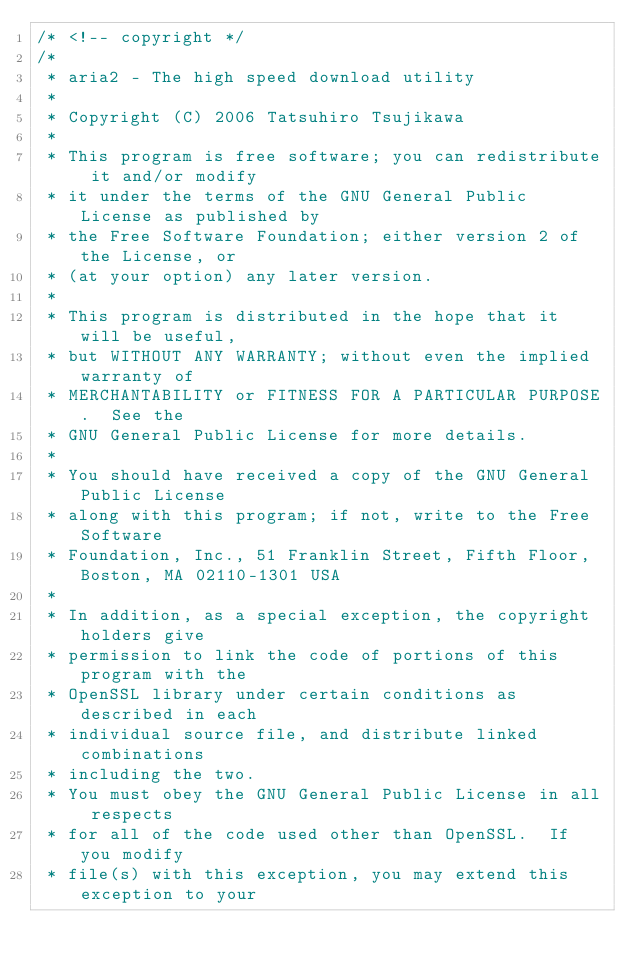Convert code to text. <code><loc_0><loc_0><loc_500><loc_500><_C++_>/* <!-- copyright */
/*
 * aria2 - The high speed download utility
 *
 * Copyright (C) 2006 Tatsuhiro Tsujikawa
 *
 * This program is free software; you can redistribute it and/or modify
 * it under the terms of the GNU General Public License as published by
 * the Free Software Foundation; either version 2 of the License, or
 * (at your option) any later version.
 *
 * This program is distributed in the hope that it will be useful,
 * but WITHOUT ANY WARRANTY; without even the implied warranty of
 * MERCHANTABILITY or FITNESS FOR A PARTICULAR PURPOSE.  See the
 * GNU General Public License for more details.
 *
 * You should have received a copy of the GNU General Public License
 * along with this program; if not, write to the Free Software
 * Foundation, Inc., 51 Franklin Street, Fifth Floor, Boston, MA 02110-1301 USA
 *
 * In addition, as a special exception, the copyright holders give
 * permission to link the code of portions of this program with the
 * OpenSSL library under certain conditions as described in each
 * individual source file, and distribute linked combinations
 * including the two.
 * You must obey the GNU General Public License in all respects
 * for all of the code used other than OpenSSL.  If you modify
 * file(s) with this exception, you may extend this exception to your</code> 